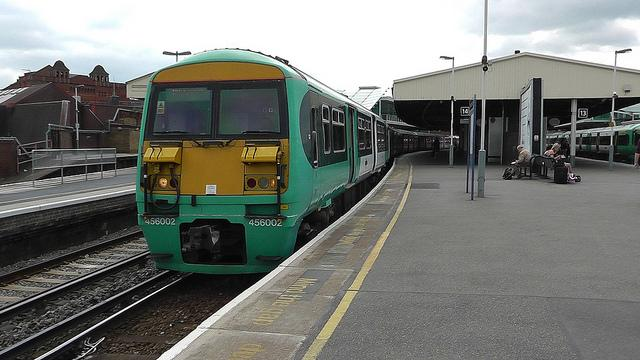What are the people on the bench doing? waiting 